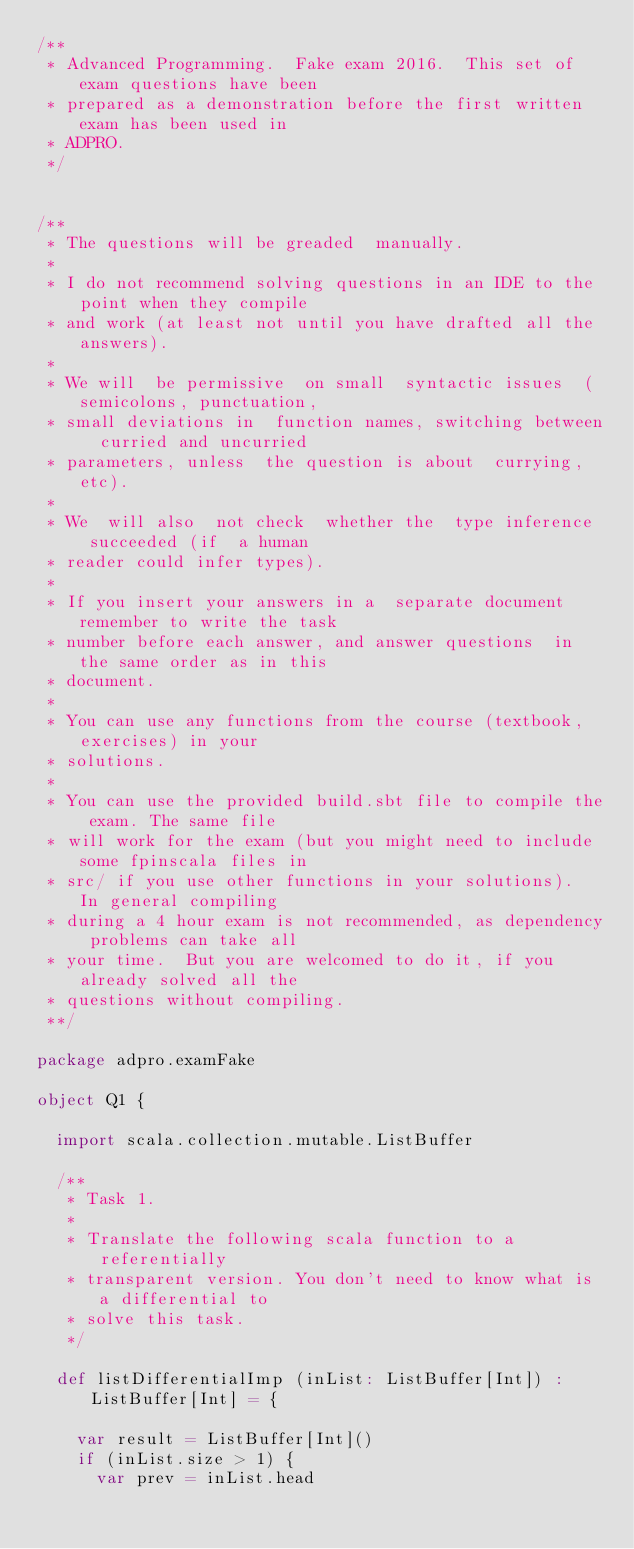<code> <loc_0><loc_0><loc_500><loc_500><_Scala_>/**
 * Advanced Programming.  Fake exam 2016.  This set of exam questions have been
 * prepared as a demonstration before the first written exam has been used in
 * ADPRO.
 */


/**
 * The questions will be greaded  manually.
 *
 * I do not recommend solving questions in an IDE to the point when they compile
 * and work (at least not until you have drafted all the answers).
 *
 * We will  be permissive  on small  syntactic issues  (semicolons, punctuation,
 * small deviations in  function names, switching between  curried and uncurried
 * parameters, unless  the question is about  currying, etc).
 *
 * We  will also  not check  whether the  type inference  succeeded (if  a human
 * reader could infer types).
 *
 * If you insert your answers in a  separate document remember to write the task
 * number before each answer, and answer questions  in the same order as in this
 * document.
 *
 * You can use any functions from the course (textbook, exercises) in your
 * solutions.
 *
 * You can use the provided build.sbt file to compile the exam. The same file
 * will work for the exam (but you might need to include some fpinscala files in
 * src/ if you use other functions in your solutions).  In general compiling
 * during a 4 hour exam is not recommended, as dependency problems can take all
 * your time.  But you are welcomed to do it, if you already solved all the
 * questions without compiling.
 **/

package adpro.examFake

object Q1 {

  import scala.collection.mutable.ListBuffer

  /**
   * Task 1.
   *
   * Translate the following scala function to a referentially
   * transparent version. You don't need to know what is a differential to
   * solve this task.
   */

  def listDifferentialImp (inList: ListBuffer[Int]) :ListBuffer[Int] = {

    var result = ListBuffer[Int]()
    if (inList.size > 1) {
      var prev = inList.head</code> 